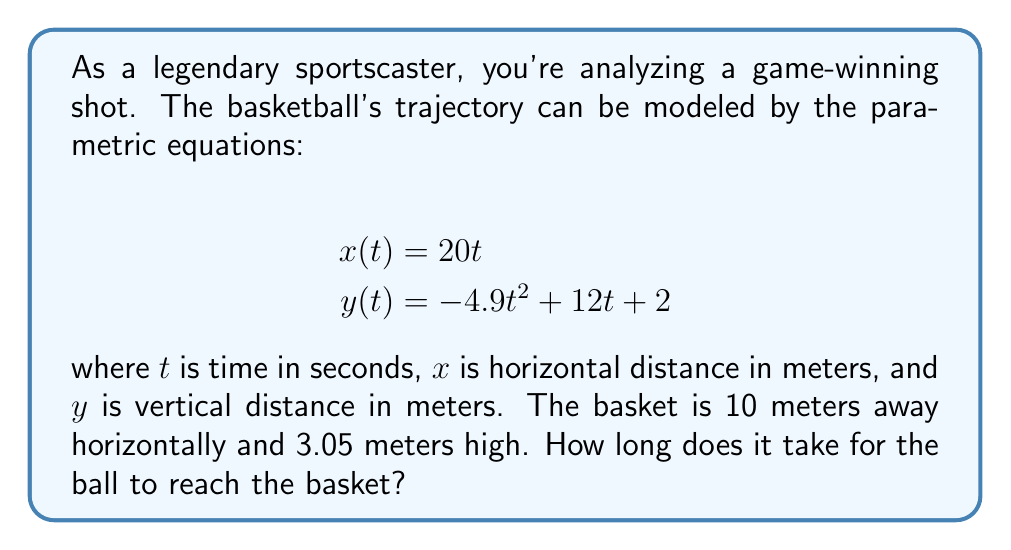Solve this math problem. To solve this problem, we'll follow these steps:

1) We know the ball reaches the basket when $x = 10$ (horizontal distance to the basket).

2) Using the equation for $x(t)$:
   $$10 = 20t$$
   $$t = 0.5\text{ seconds}$$

3) Now we need to check if the ball is at the correct height (3.05 meters) at this time.

4) Substitute $t = 0.5$ into the equation for $y(t)$:
   $$y(0.5) = -4.9(0.5)^2 + 12(0.5) + 2$$
   $$= -4.9(0.25) + 6 + 2$$
   $$= -1.225 + 8$$
   $$= 6.775\text{ meters}$$

5) The ball is at 6.775 meters when it reaches the horizontal position of the basket, which is higher than the basket's height of 3.05 meters.

6) This means the ball will pass through the basket's height at some point before reaching the 10-meter mark horizontally.

7) To find the exact time when the ball is at basket height, we solve:
   $$3.05 = -4.9t^2 + 12t + 2$$
   $$0 = -4.9t^2 + 12t - 1.05$$

8) This is a quadratic equation. We can solve it using the quadratic formula:
   $$t = \frac{-b \pm \sqrt{b^2 - 4ac}}{2a}$$
   where $a = -4.9$, $b = 12$, and $c = -1.05$

9) Solving this gives us two solutions: $t \approx 0.2439$ or $t \approx 2.2049$

10) The smaller value, 0.2439 seconds, is the time it takes for the ball to reach the basket.
Answer: 0.2439 seconds 